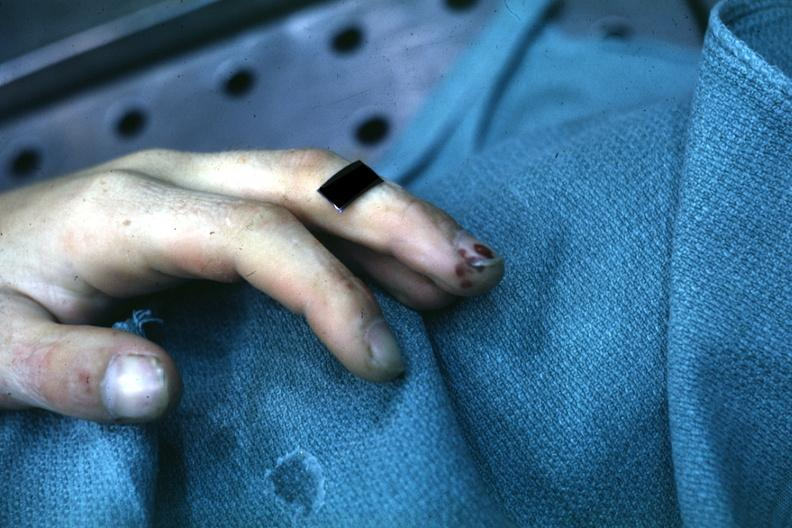what are present?
Answer the question using a single word or phrase. Extremities 